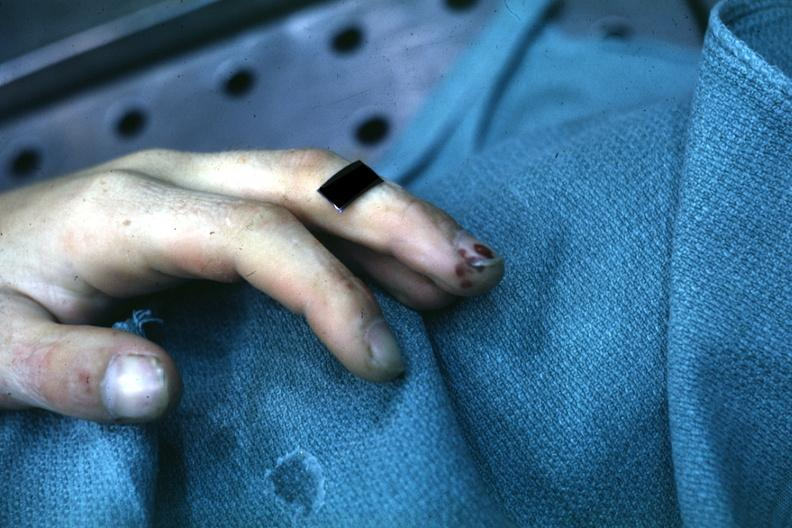what are present?
Answer the question using a single word or phrase. Extremities 